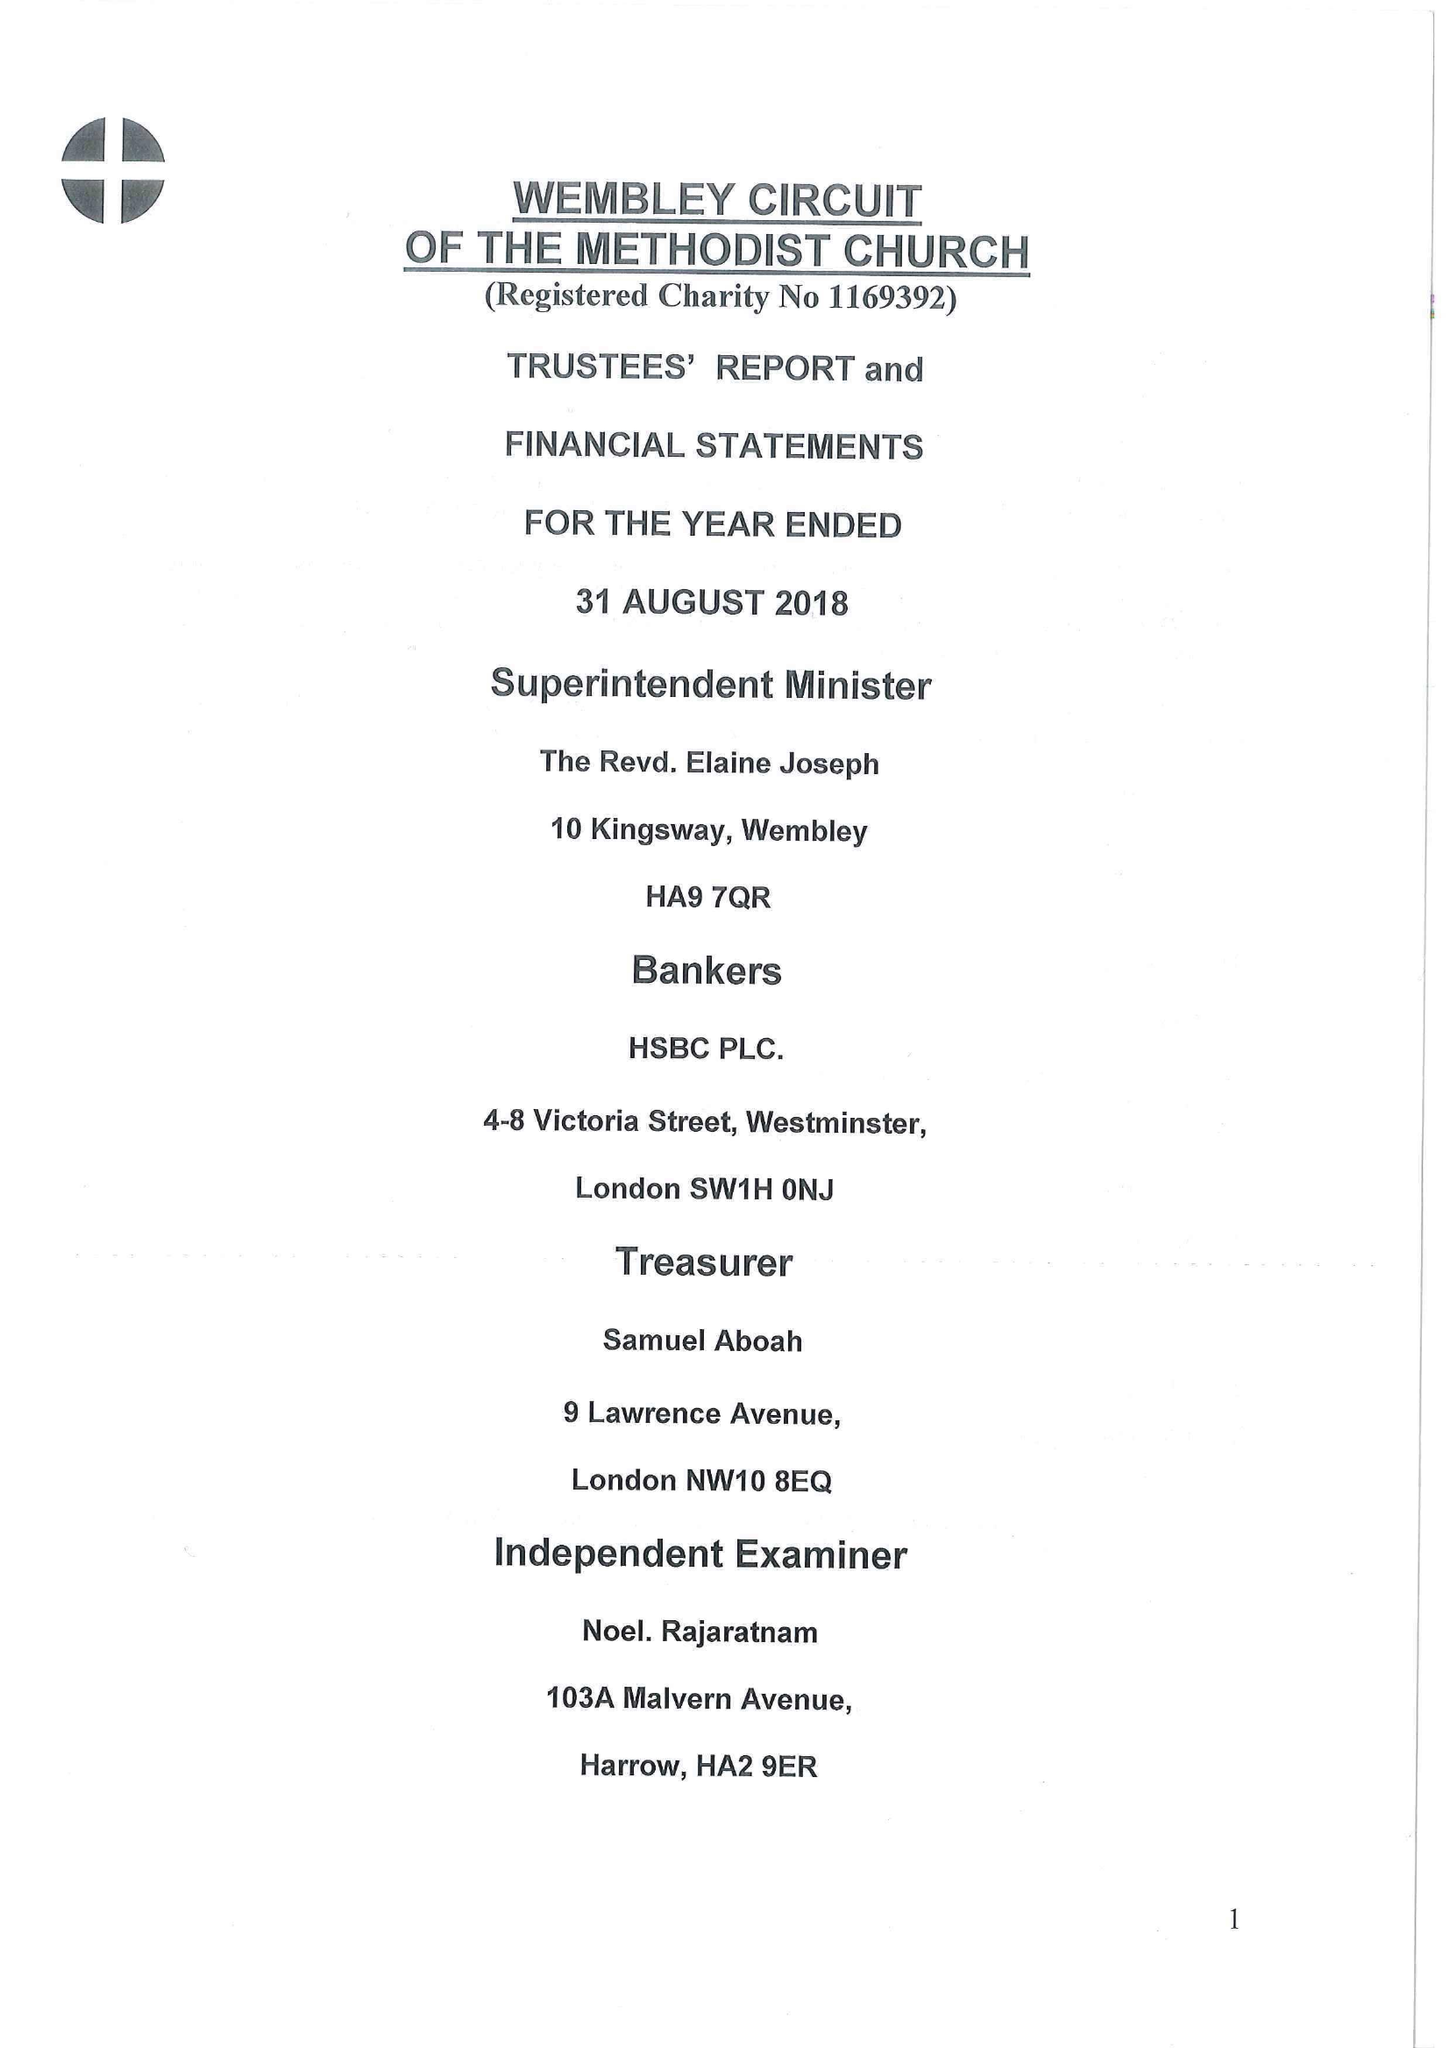What is the value for the address__post_town?
Answer the question using a single word or phrase. WEMBLEY 